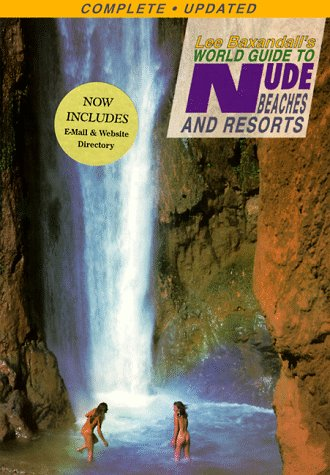What additional features does this edition of the book include? The updated edition includes email and website directories, offering readers accessible online resources to enhance their travel planning. 